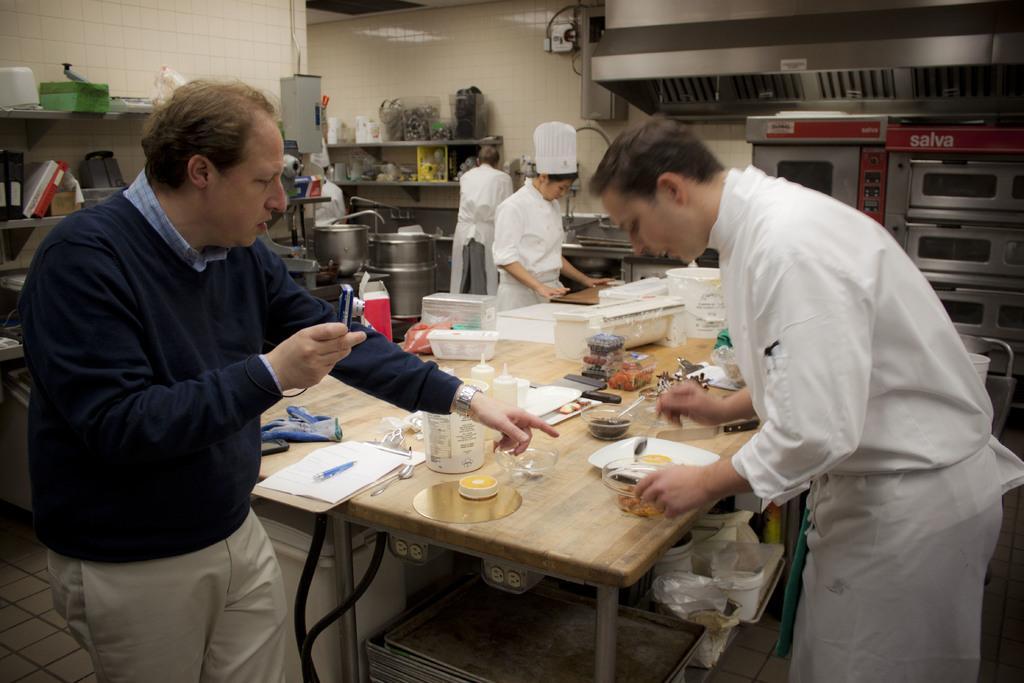How would you summarize this image in a sentence or two? In this picture we can see persons standing near to the table and on the table we can see pad, paper, pen, plate, spoon, box of food and few things. Here near to the wall and kitchen platform we can see two chefs standing and working. This is a floor. 